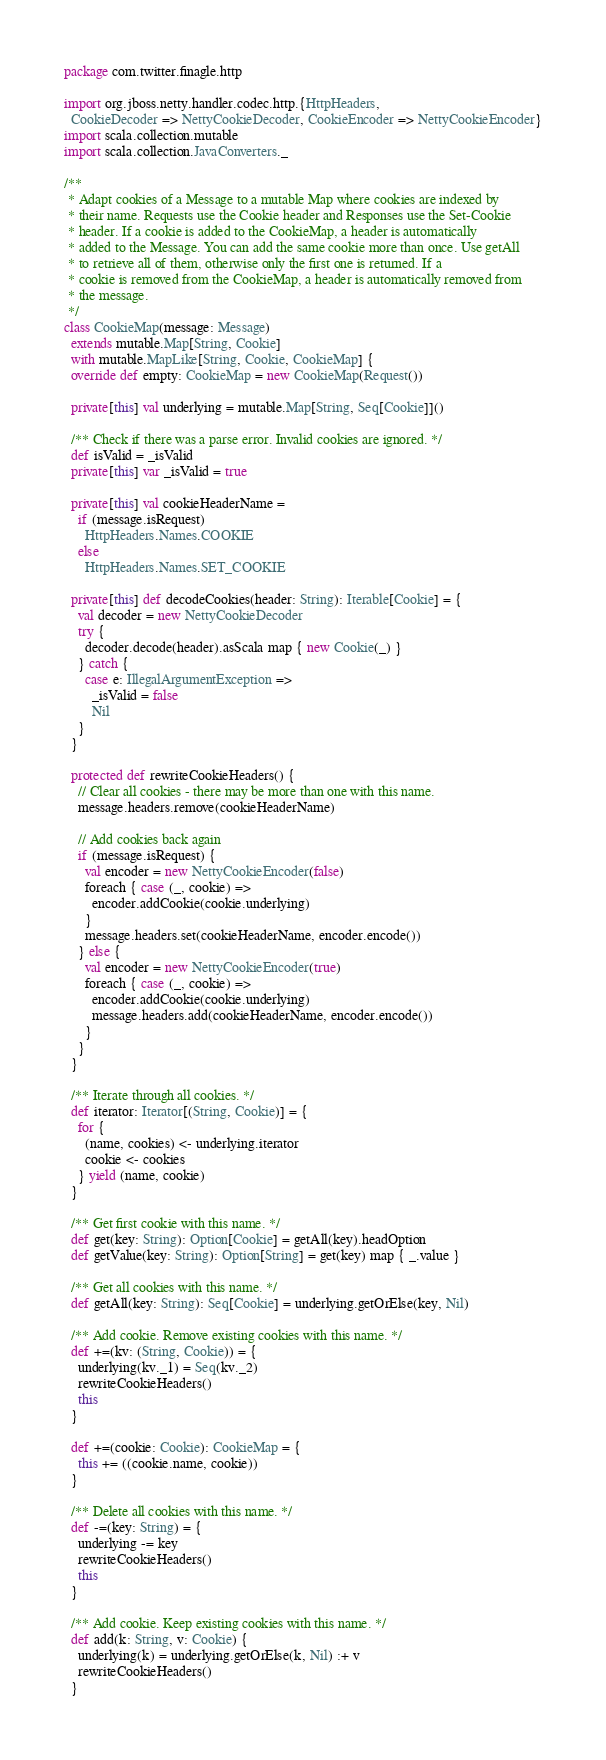<code> <loc_0><loc_0><loc_500><loc_500><_Scala_>package com.twitter.finagle.http

import org.jboss.netty.handler.codec.http.{HttpHeaders,
  CookieDecoder => NettyCookieDecoder, CookieEncoder => NettyCookieEncoder}
import scala.collection.mutable
import scala.collection.JavaConverters._

/**
 * Adapt cookies of a Message to a mutable Map where cookies are indexed by
 * their name. Requests use the Cookie header and Responses use the Set-Cookie
 * header. If a cookie is added to the CookieMap, a header is automatically
 * added to the Message. You can add the same cookie more than once. Use getAll
 * to retrieve all of them, otherwise only the first one is returned. If a
 * cookie is removed from the CookieMap, a header is automatically removed from
 * the message.
 */
class CookieMap(message: Message)
  extends mutable.Map[String, Cookie]
  with mutable.MapLike[String, Cookie, CookieMap] {
  override def empty: CookieMap = new CookieMap(Request())

  private[this] val underlying = mutable.Map[String, Seq[Cookie]]()

  /** Check if there was a parse error. Invalid cookies are ignored. */
  def isValid = _isValid
  private[this] var _isValid = true

  private[this] val cookieHeaderName =
    if (message.isRequest)
      HttpHeaders.Names.COOKIE
    else
      HttpHeaders.Names.SET_COOKIE

  private[this] def decodeCookies(header: String): Iterable[Cookie] = {
    val decoder = new NettyCookieDecoder
    try {
      decoder.decode(header).asScala map { new Cookie(_) }
    } catch {
      case e: IllegalArgumentException =>
        _isValid = false
        Nil
    }
  }

  protected def rewriteCookieHeaders() {
    // Clear all cookies - there may be more than one with this name.
    message.headers.remove(cookieHeaderName)

    // Add cookies back again
    if (message.isRequest) {
      val encoder = new NettyCookieEncoder(false)
      foreach { case (_, cookie) =>
        encoder.addCookie(cookie.underlying)
      }
      message.headers.set(cookieHeaderName, encoder.encode())
    } else {
      val encoder = new NettyCookieEncoder(true)
      foreach { case (_, cookie) =>
        encoder.addCookie(cookie.underlying)
        message.headers.add(cookieHeaderName, encoder.encode())
      }
    }
  }

  /** Iterate through all cookies. */
  def iterator: Iterator[(String, Cookie)] = {
    for {
      (name, cookies) <- underlying.iterator
      cookie <- cookies
    } yield (name, cookie)
  }

  /** Get first cookie with this name. */
  def get(key: String): Option[Cookie] = getAll(key).headOption
  def getValue(key: String): Option[String] = get(key) map { _.value }

  /** Get all cookies with this name. */
  def getAll(key: String): Seq[Cookie] = underlying.getOrElse(key, Nil)

  /** Add cookie. Remove existing cookies with this name. */
  def +=(kv: (String, Cookie)) = {
    underlying(kv._1) = Seq(kv._2)
    rewriteCookieHeaders()
    this
  }

  def +=(cookie: Cookie): CookieMap = {
    this += ((cookie.name, cookie))
  }

  /** Delete all cookies with this name. */
  def -=(key: String) = {
    underlying -= key
    rewriteCookieHeaders()
    this
  }

  /** Add cookie. Keep existing cookies with this name. */
  def add(k: String, v: Cookie) {
    underlying(k) = underlying.getOrElse(k, Nil) :+ v
    rewriteCookieHeaders()
  }
</code> 